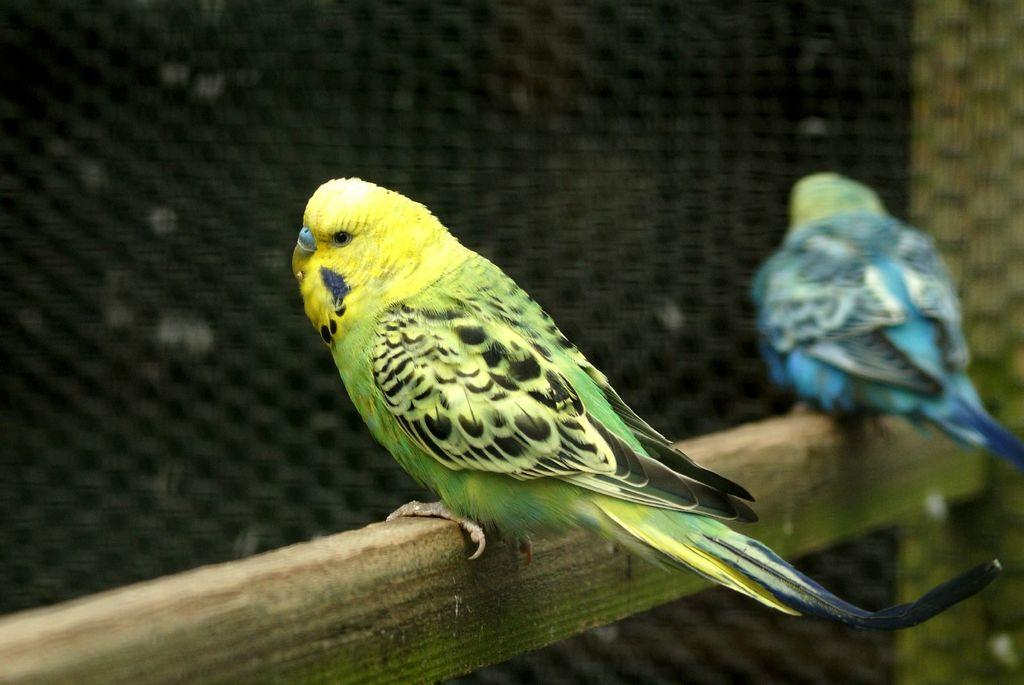How many birds are present in the image? There are two birds in the image. What colors can be seen on the birds? The colors of the birds are blue, green, and black. Can you describe the overall quality of the image? The image is slightly blurry in the background. What type of pin can be seen holding a leaf in the image? There is no pin or leaf present in the image; it features two birds with specific colors. 